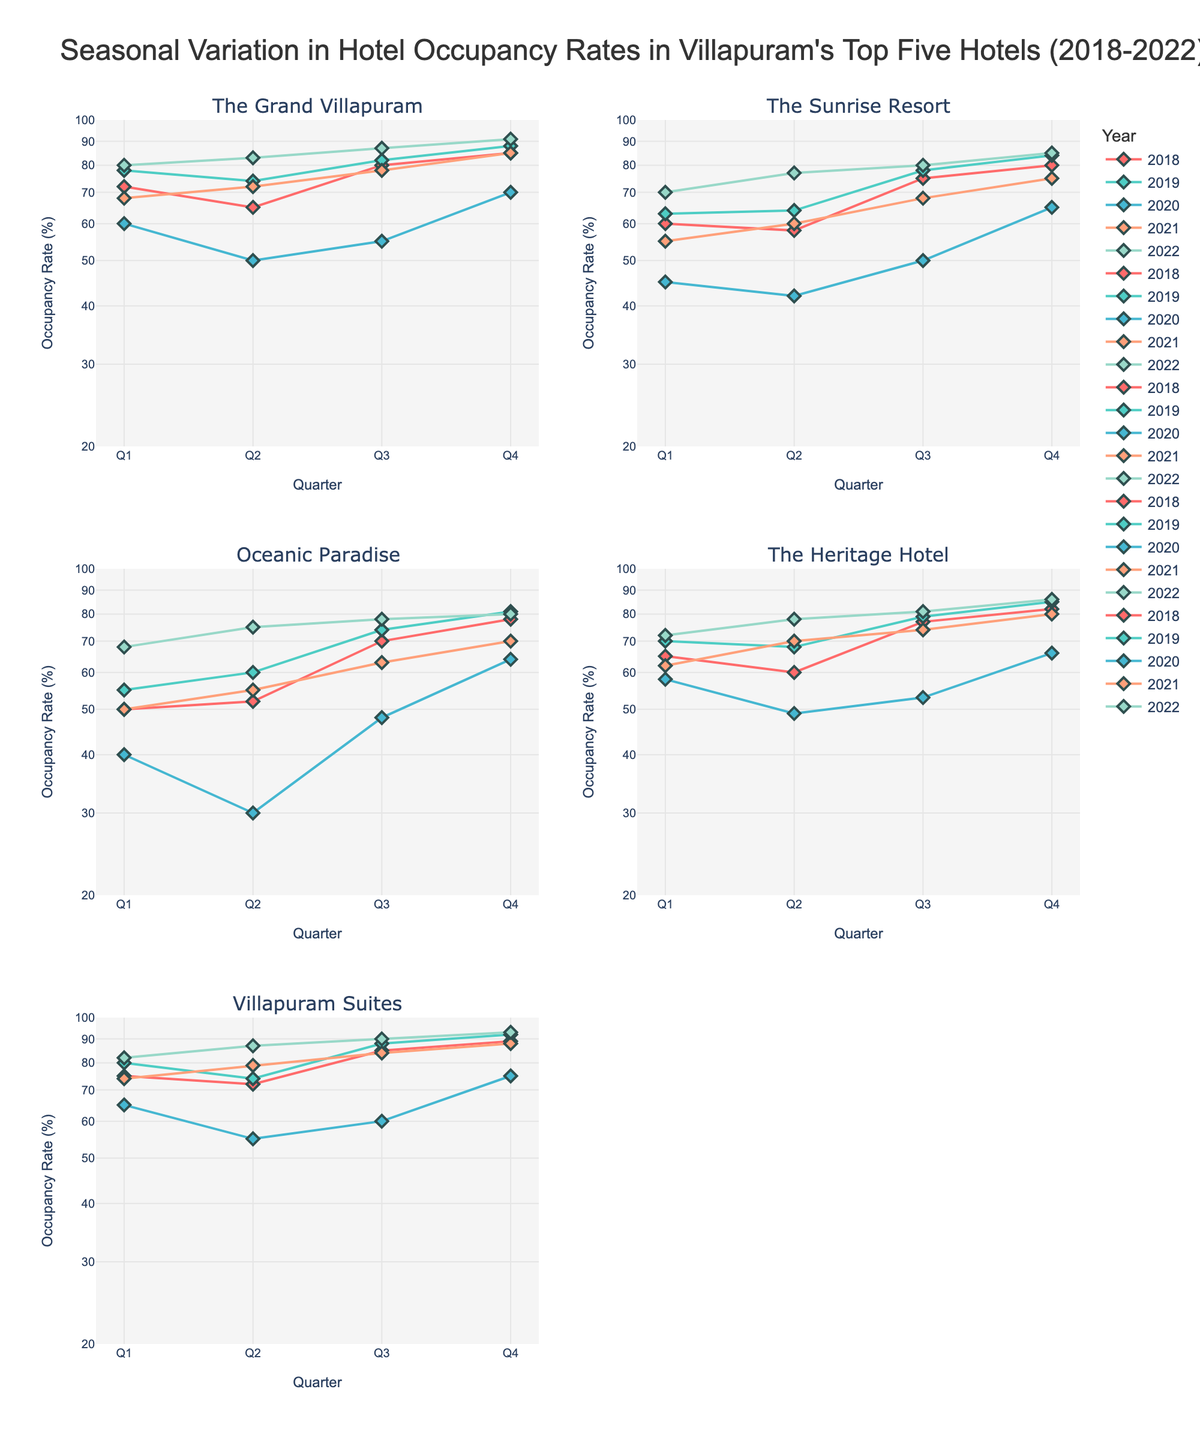What's the overall trend in hotel occupancy rates from 2020 to 2022 across all hotels? To determine the trend, examine the graphs for each hotel and look at the lines representing the years 2020, 2021, and 2022. The lines generally show an increasing trend from 2020 (low rates mainly due to the pandemic) to 2022 (recovery phase with higher rates) across all hotels.
Answer: Increasing Which hotel had the highest occupancy rate in Q4 of 2022? To find this, look at the data points for Q4 2022 across all subplots. Villapuram Suites has the highest occupancy rate among the hotels with 93%.
Answer: Villapuram Suites Compared to 2019, did the occupancy rate in Q1 2020 decrease or increase for The Grand Villapuram? By how much? Compare the Q1 occupancy rates for 2019 and 2020 for The Grand Villapuram to find the difference. In 2019, Q1 is 78%, while in 2020 it is 60%. The decrease is 78% - 60% = 18%.
Answer: Decrease by 18% What pattern do you observe in the occupancy rates for The Sunrise Resort in the second quarter over the years? Inspect the occupancy rates for Q2 in The Sunrise Resort subplot. The rates show a pattern of gradual increase over the years, with a dip in 2020, and then recovery in 2021 and 2022.
Answer: Gradual increase with a dip in 2020 Which hotel had the most consistent occupancy rates across all quarters from 2018 to 2022 on a log scale? To find consistency, observe the smoothness and uniformity in the plot lines across all years for each hotel. The Grand Villapuram shows the least fluctuations on the log scale plot compared to others.
Answer: The Grand Villapuram How did the occupancy rate in Villapuram Suites in Q3 change from 2020 to 2022 and what was the percentage change? Check the occupancy rates for Q3 2020 (60%) and Q3 2022 (90%) for Villapuram Suites. Calculate the percentage change: ((90 - 60) / 60) * 100 = 50%.
Answer: Increased by 50% What is the y-axis range, and why is it significant? The y-axis is in a logarithmic scale ranging from 20% to 100%. This scale is used to better visualize the performance differences and trends, especially when data values span over a large range.
Answer: Logarithmic scale from 20% to 100% Which quarter consistently had the lowest occupancy rates across nearly all hotels during the pandemic year of 2020? Examine the subplots for the year 2020 and identify the lowest occupancy rates in different quarters. Q2 consistently shows the lowest rates across all hotels.
Answer: Q2 What was the impact of the pandemic on The Heritage Hotel's occupancy rate in Q2 2020 compared to Q2 2019? Compare Q2 2019 (68%) to Q2 2020 (49%) occupancy rates for The Heritage Hotel. The impact is a significant drop of 68% - 49% = 19%.
Answer: Significant drop of 19% 